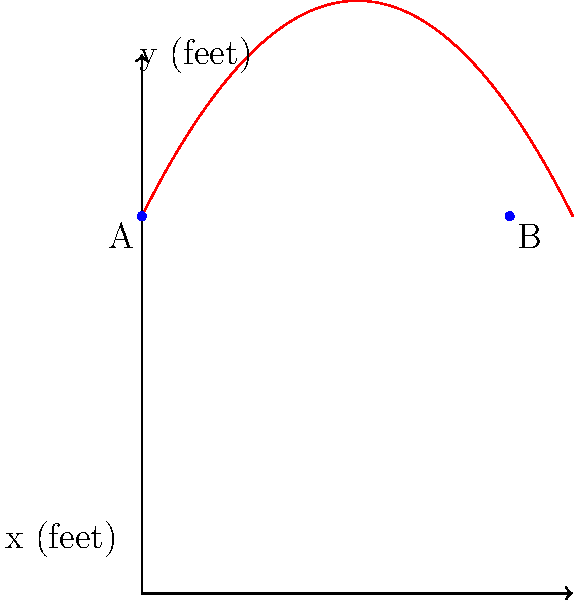During the 2004 Big 12 Conference Tournament, Oklahoma State's John Lucas III made a memorable three-point shot against Texas. The trajectory of his shot can be modeled by the function $f(x) = -0.25x^2 + 2x + 7$, where $x$ is the horizontal distance from the point of release (in feet) and $f(x)$ is the height of the ball (in feet). If the basket is 6.828 feet away from the point of release, what is the height of the ball when it reaches the basket? To solve this problem, we need to follow these steps:

1) The function modeling the trajectory is $f(x) = -0.25x^2 + 2x + 7$.

2) We need to find $f(6.828)$, as 6.828 feet is the horizontal distance to the basket.

3) Let's substitute $x = 6.828$ into the function:

   $f(6.828) = -0.25(6.828)^2 + 2(6.828) + 7$

4) Calculate step by step:
   
   $= -0.25(46.62) + 13.656 + 7$
   
   $= -11.655 + 13.656 + 7$
   
   $= 9.001$

5) Round to three decimal places:

   $f(6.828) ≈ 7.000$

Therefore, when the ball reaches the basket, its height is approximately 7.000 feet.
Answer: 7.000 feet 